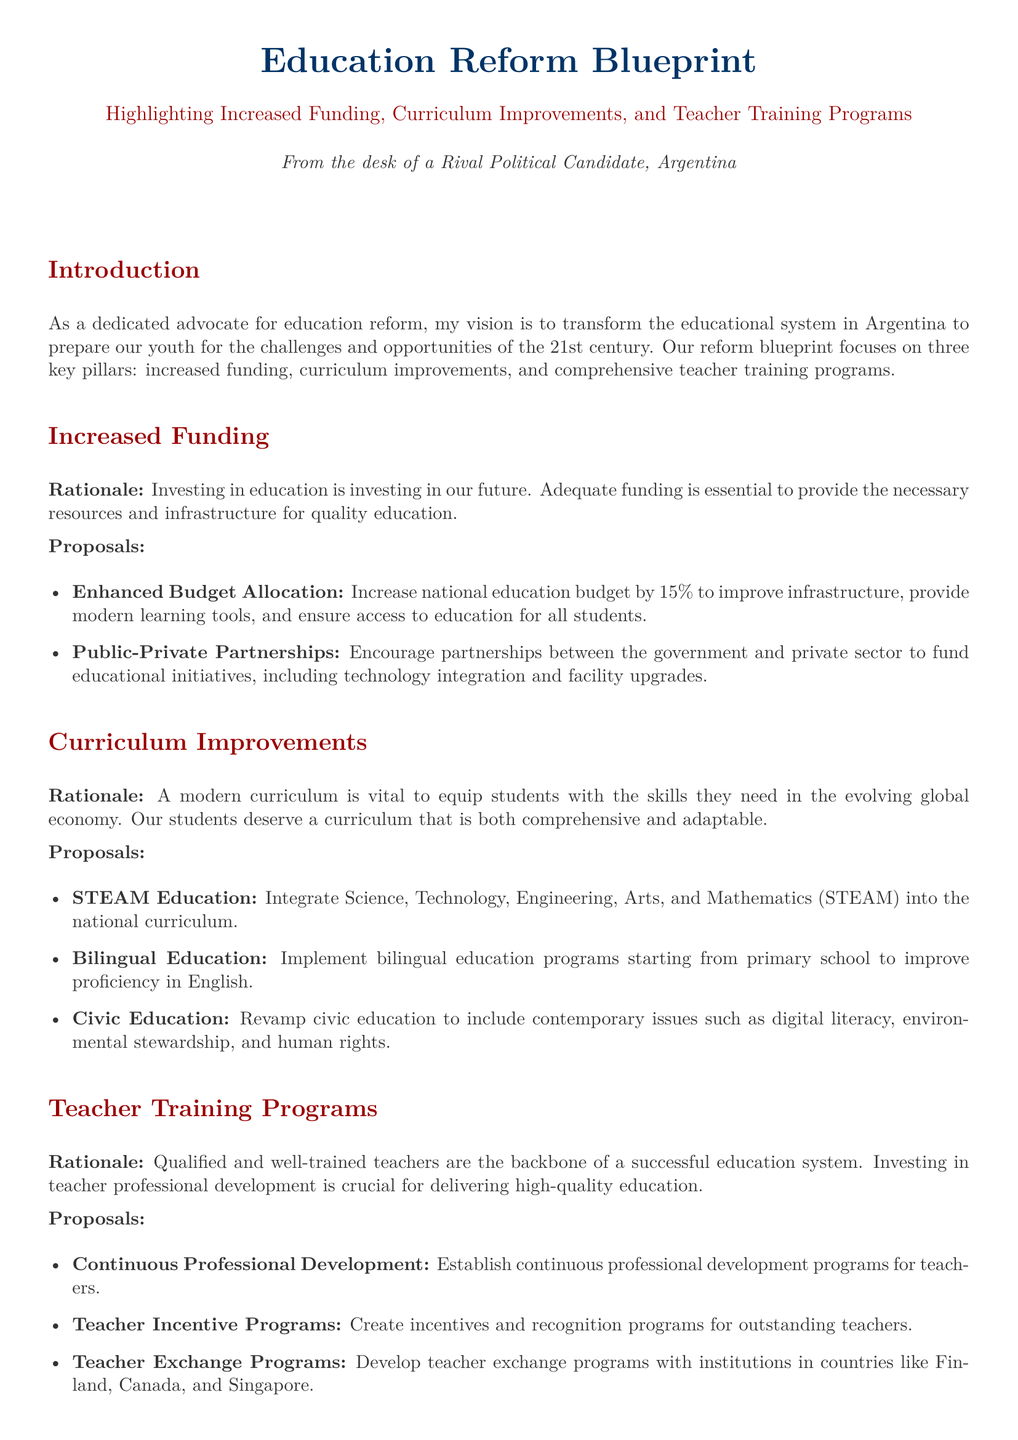What are the key pillars of the education reform blueprint? The three key pillars highlighted are increased funding, curriculum improvements, and comprehensive teacher training programs.
Answer: Increased funding, curriculum improvements, and comprehensive teacher training programs What percentage increase is proposed for the national education budget? The document states a specific percentage increase in the national education budget, which is 15%.
Answer: 15% What is one of the proposed subjects to be integrated into the national curriculum? The document mentions STEAM education as one of the proposed subjects to be integrated into the national curriculum.
Answer: STEAM education What type of education program is proposed to start from primary school? The proposal includes implementing bilingual education programs, starting from primary school.
Answer: Bilingual education Which country is mentioned for potential teacher exchange programs? The document lists several countries for teacher exchange programs, one of which is Finland.
Answer: Finland What is the rationale for increased funding in education? The rationale provided for increased funding is that investing in education is an investment in the future.
Answer: Investing in education is investing in our future What type of programs is proposed for teacher professional development? The document proposes establishing continuous professional development programs for teachers.
Answer: Continuous professional development programs What contemporary issues are incorporated into the revamped civic education? The revamped civic education includes contemporary issues such as digital literacy, environmental stewardship, and human rights.
Answer: Digital literacy, environmental stewardship, and human rights What incentive is proposed for outstanding teachers? The proposal includes creating incentives and recognition programs for outstanding teachers.
Answer: Incentives and recognition programs 